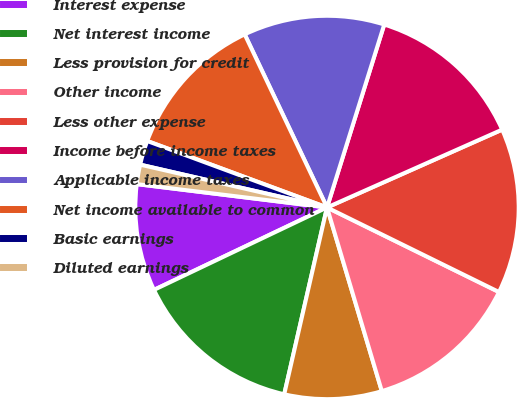<chart> <loc_0><loc_0><loc_500><loc_500><pie_chart><fcel>Interest expense<fcel>Net interest income<fcel>Less provision for credit<fcel>Other income<fcel>Less other expense<fcel>Income before income taxes<fcel>Applicable income taxes<fcel>Net income available to common<fcel>Basic earnings<fcel>Diluted earnings<nl><fcel>9.02%<fcel>14.34%<fcel>8.2%<fcel>13.11%<fcel>13.93%<fcel>13.52%<fcel>11.89%<fcel>12.3%<fcel>2.05%<fcel>1.64%<nl></chart> 